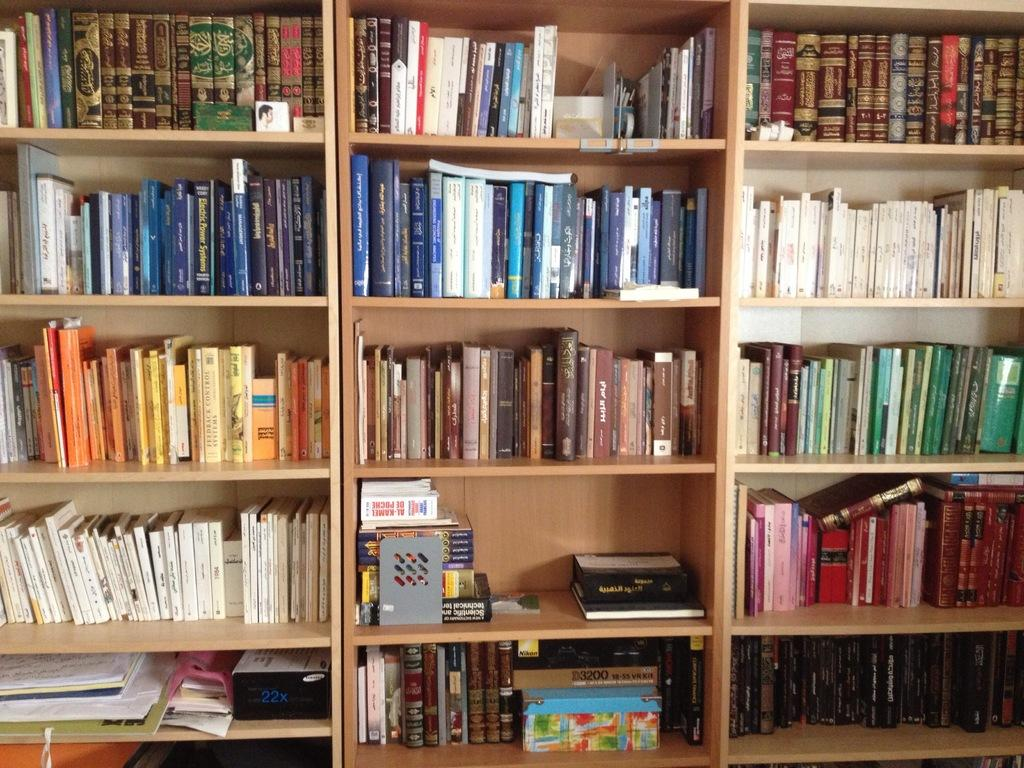What type of items can be seen in the image? There are books and objects in the image. How are the books and objects arranged in the image? The books and objects are in racks. What type of fear can be seen on the giraffe's face in the image? There is no giraffe present in the image, so it is not possible to determine any fear on its face. 